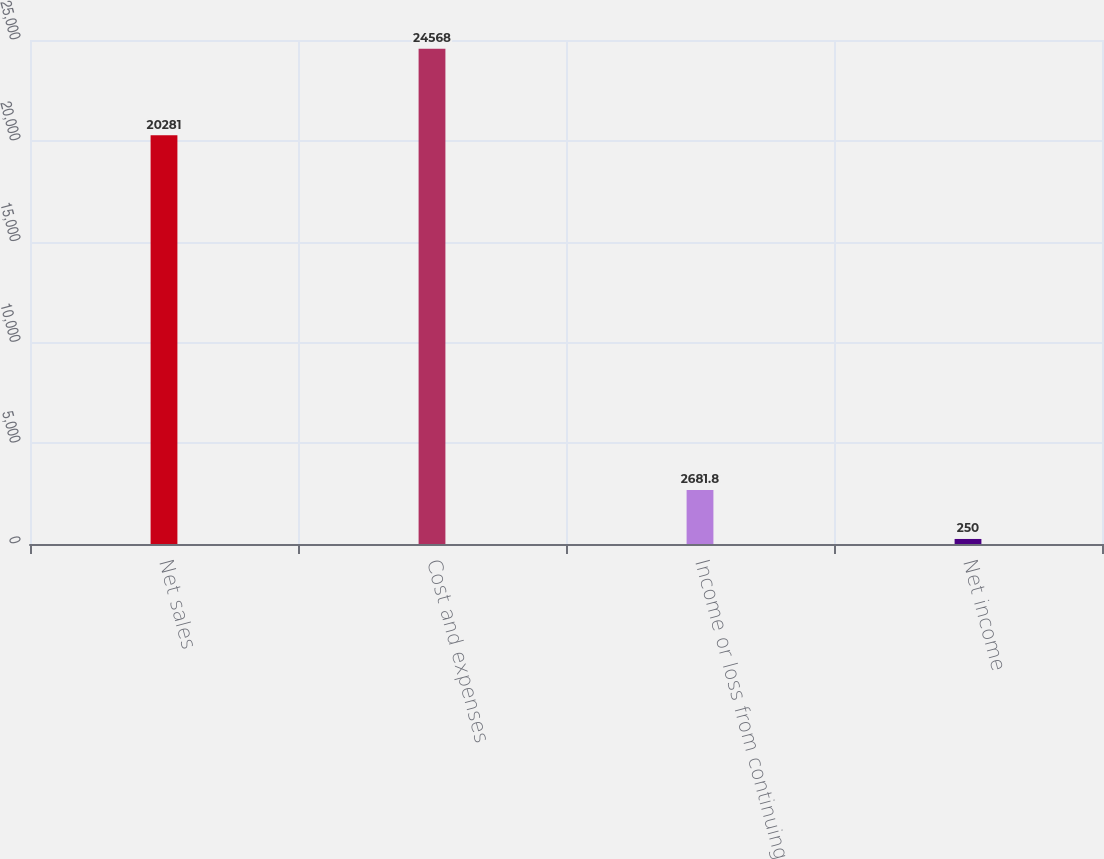<chart> <loc_0><loc_0><loc_500><loc_500><bar_chart><fcel>Net sales<fcel>Cost and expenses<fcel>Income or loss from continuing<fcel>Net income<nl><fcel>20281<fcel>24568<fcel>2681.8<fcel>250<nl></chart> 